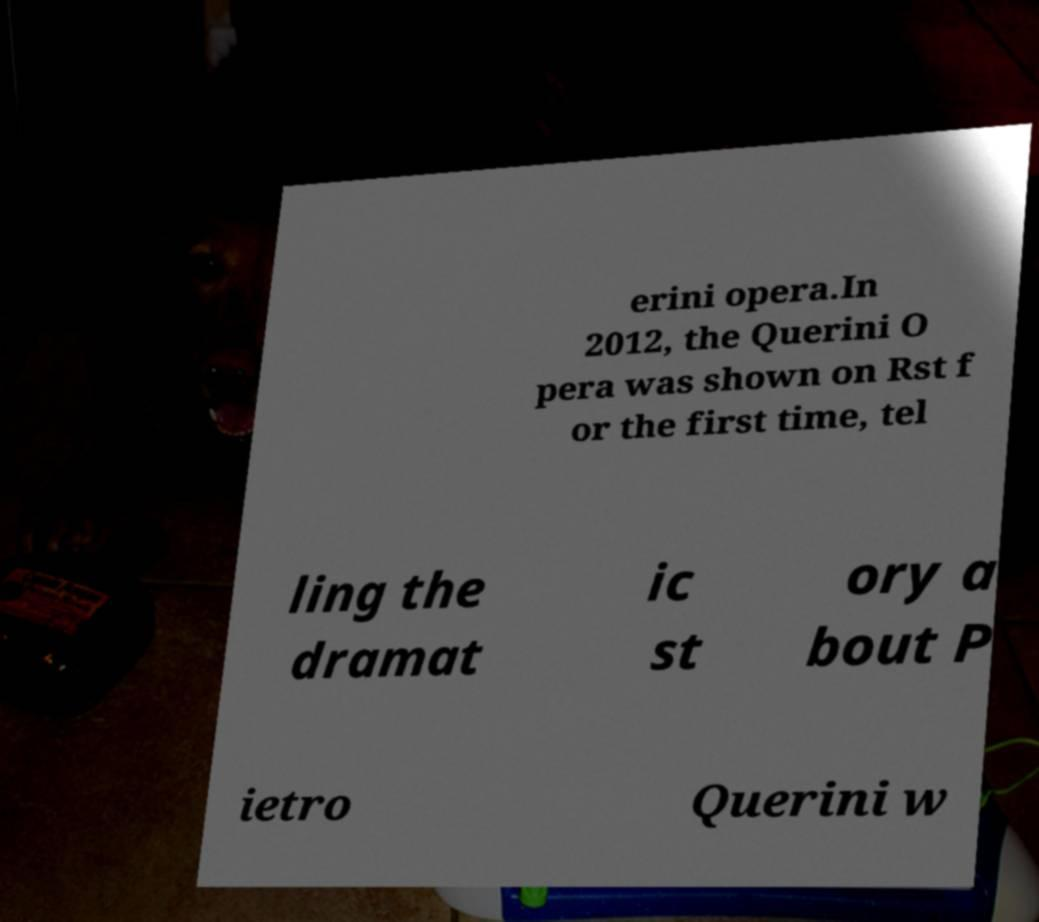Could you assist in decoding the text presented in this image and type it out clearly? erini opera.In 2012, the Querini O pera was shown on Rst f or the first time, tel ling the dramat ic st ory a bout P ietro Querini w 